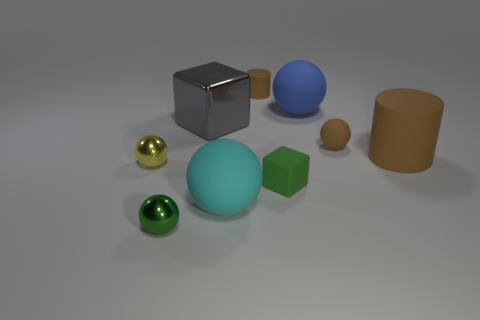Subtract all green balls. How many balls are left? 4 Subtract all cyan spheres. How many spheres are left? 4 Subtract all spheres. How many objects are left? 4 Add 6 blue rubber spheres. How many blue rubber spheres are left? 7 Add 6 small purple matte cylinders. How many small purple matte cylinders exist? 6 Subtract 0 purple cubes. How many objects are left? 9 Subtract 1 cylinders. How many cylinders are left? 1 Subtract all green balls. Subtract all purple cubes. How many balls are left? 4 Subtract all yellow matte things. Subtract all tiny green rubber things. How many objects are left? 8 